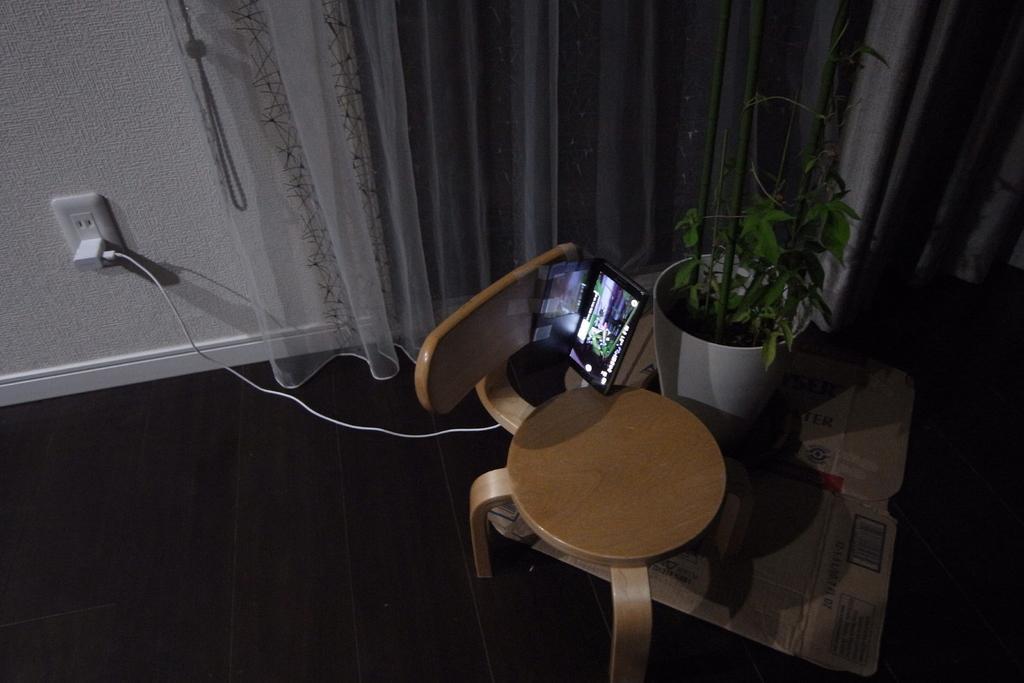Describe this image in one or two sentences. In this image we can see a chair, tablet and pot on the black floor. At the top white wall and curtain is there and one switch board is attached to the wall. And charger is attached to the switch board. 